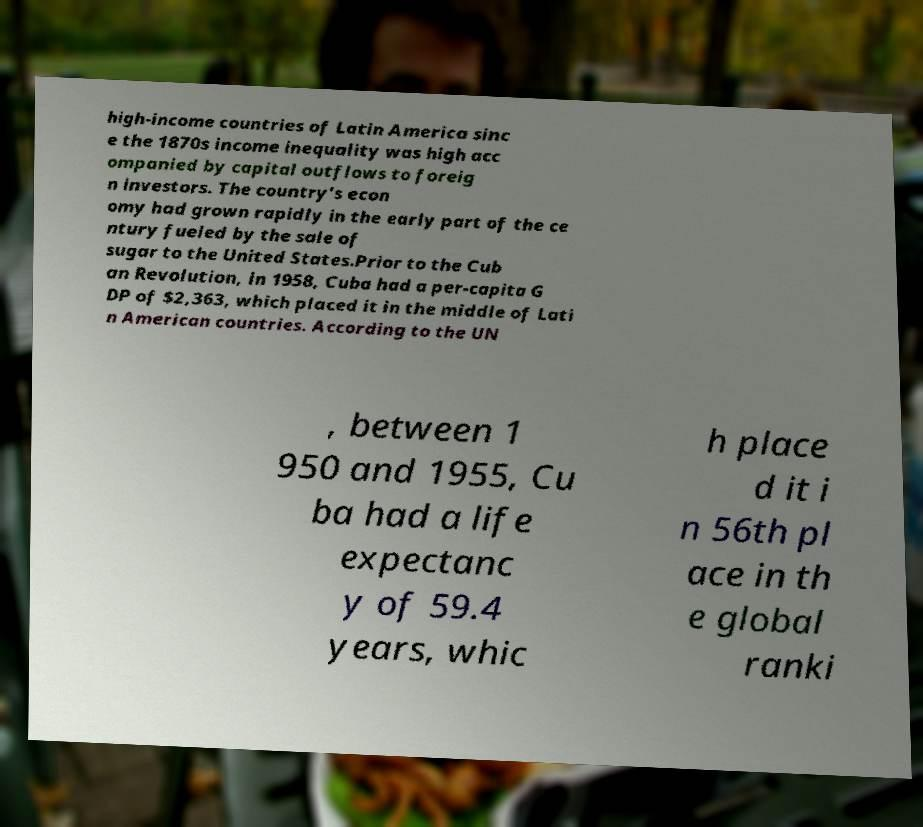Could you assist in decoding the text presented in this image and type it out clearly? high-income countries of Latin America sinc e the 1870s income inequality was high acc ompanied by capital outflows to foreig n investors. The country's econ omy had grown rapidly in the early part of the ce ntury fueled by the sale of sugar to the United States.Prior to the Cub an Revolution, in 1958, Cuba had a per-capita G DP of $2,363, which placed it in the middle of Lati n American countries. According to the UN , between 1 950 and 1955, Cu ba had a life expectanc y of 59.4 years, whic h place d it i n 56th pl ace in th e global ranki 